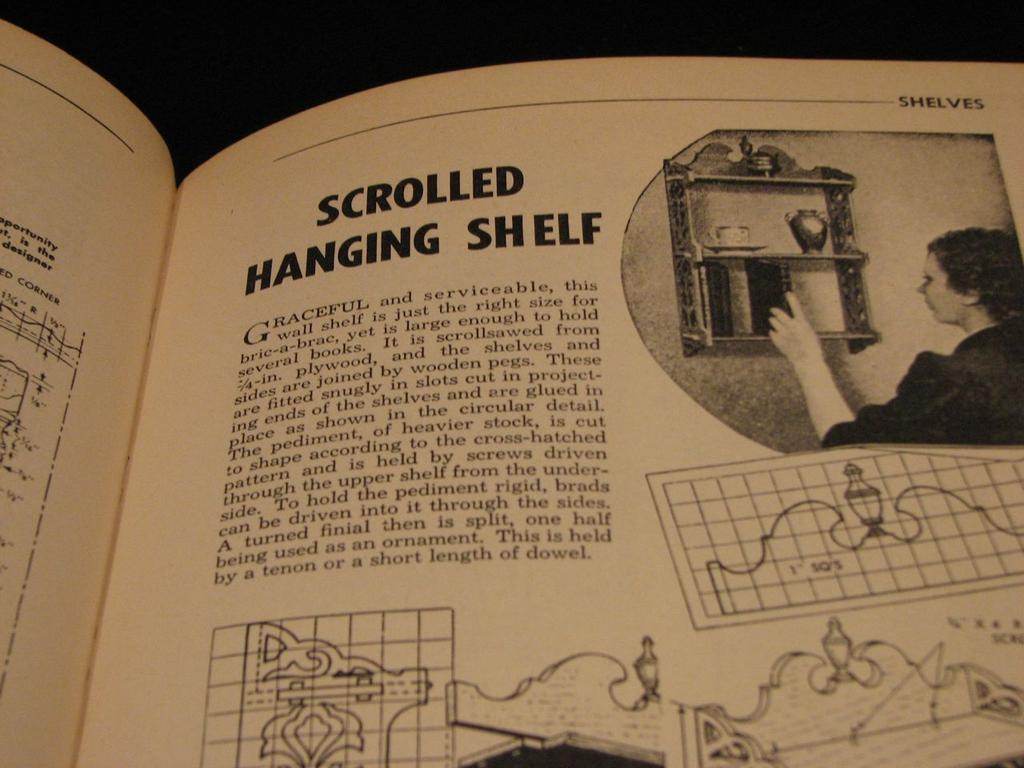What is in big bold letters at the top of the page?
Give a very brief answer. Scrolled hanging shelf. Which book is this?
Give a very brief answer. Unanswerable. 